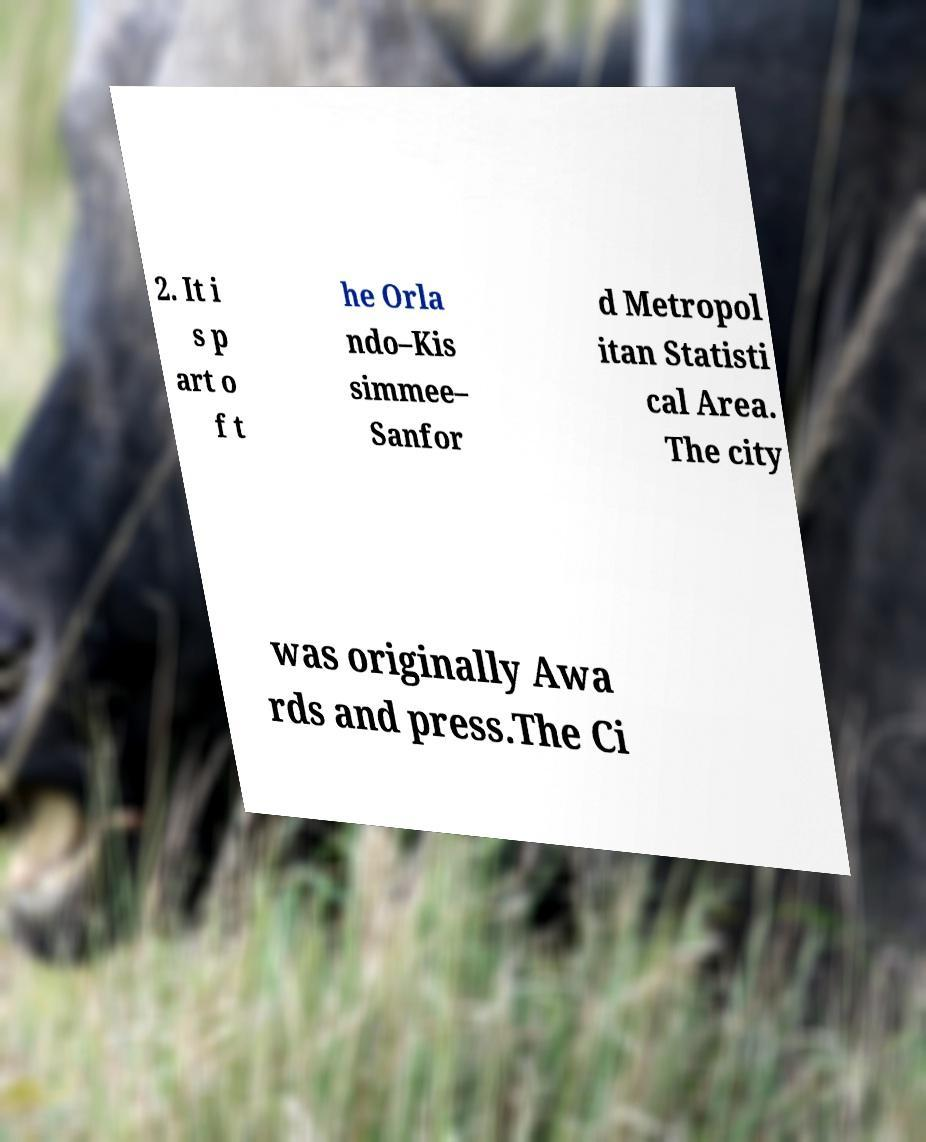There's text embedded in this image that I need extracted. Can you transcribe it verbatim? 2. It i s p art o f t he Orla ndo–Kis simmee– Sanfor d Metropol itan Statisti cal Area. The city was originally Awa rds and press.The Ci 